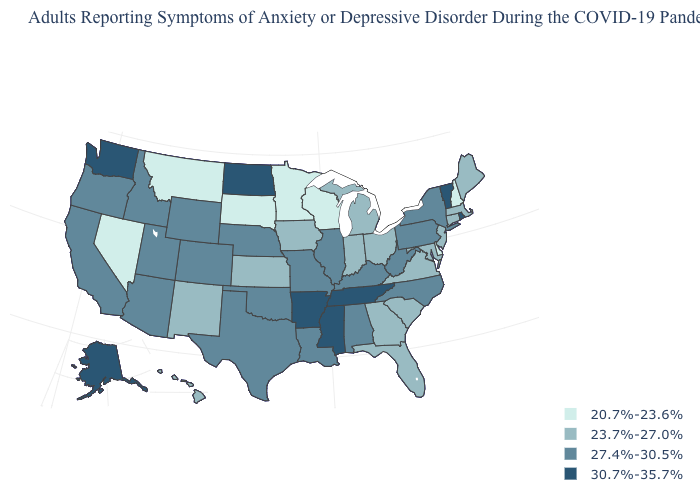Does North Dakota have the highest value in the MidWest?
Answer briefly. Yes. What is the value of Delaware?
Short answer required. 20.7%-23.6%. Does Wisconsin have a lower value than Minnesota?
Be succinct. No. Among the states that border Indiana , which have the lowest value?
Keep it brief. Michigan, Ohio. Does Maine have the lowest value in the USA?
Keep it brief. No. Name the states that have a value in the range 27.4%-30.5%?
Keep it brief. Alabama, Arizona, California, Colorado, Idaho, Illinois, Kentucky, Louisiana, Missouri, Nebraska, New York, North Carolina, Oklahoma, Oregon, Pennsylvania, Texas, Utah, West Virginia, Wyoming. Does Nevada have the lowest value in the USA?
Keep it brief. Yes. What is the value of Alaska?
Give a very brief answer. 30.7%-35.7%. What is the value of New Jersey?
Answer briefly. 23.7%-27.0%. What is the value of Delaware?
Answer briefly. 20.7%-23.6%. What is the lowest value in the USA?
Answer briefly. 20.7%-23.6%. Name the states that have a value in the range 20.7%-23.6%?
Answer briefly. Delaware, Minnesota, Montana, Nevada, New Hampshire, South Dakota, Wisconsin. What is the value of Oregon?
Write a very short answer. 27.4%-30.5%. Which states hav the highest value in the MidWest?
Keep it brief. North Dakota. Among the states that border Kansas , which have the highest value?
Concise answer only. Colorado, Missouri, Nebraska, Oklahoma. 